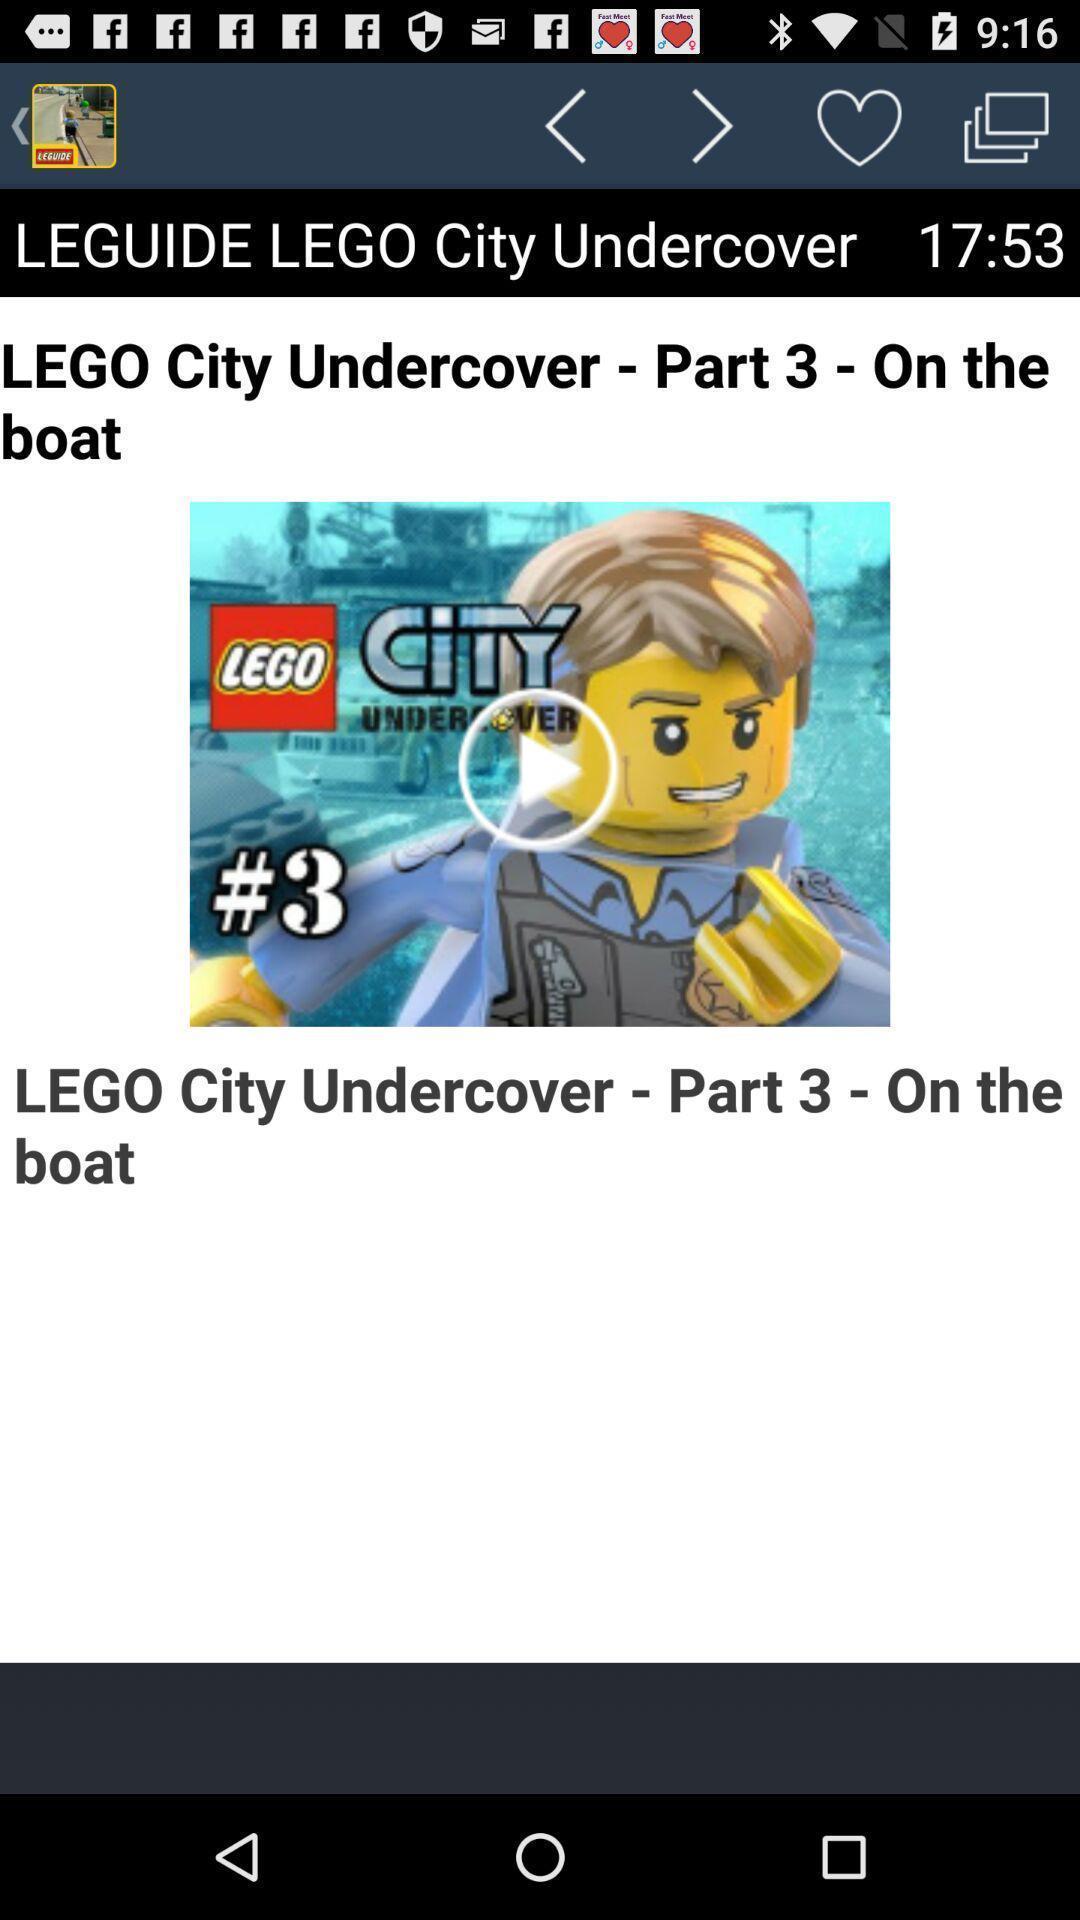Describe the visual elements of this screenshot. Video guide of a video game. 